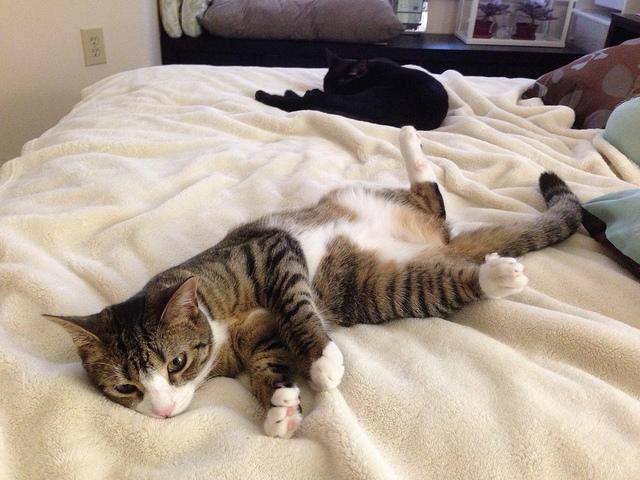How many cats are visible?
Give a very brief answer. 2. How many people have at least one shoulder exposed?
Give a very brief answer. 0. 